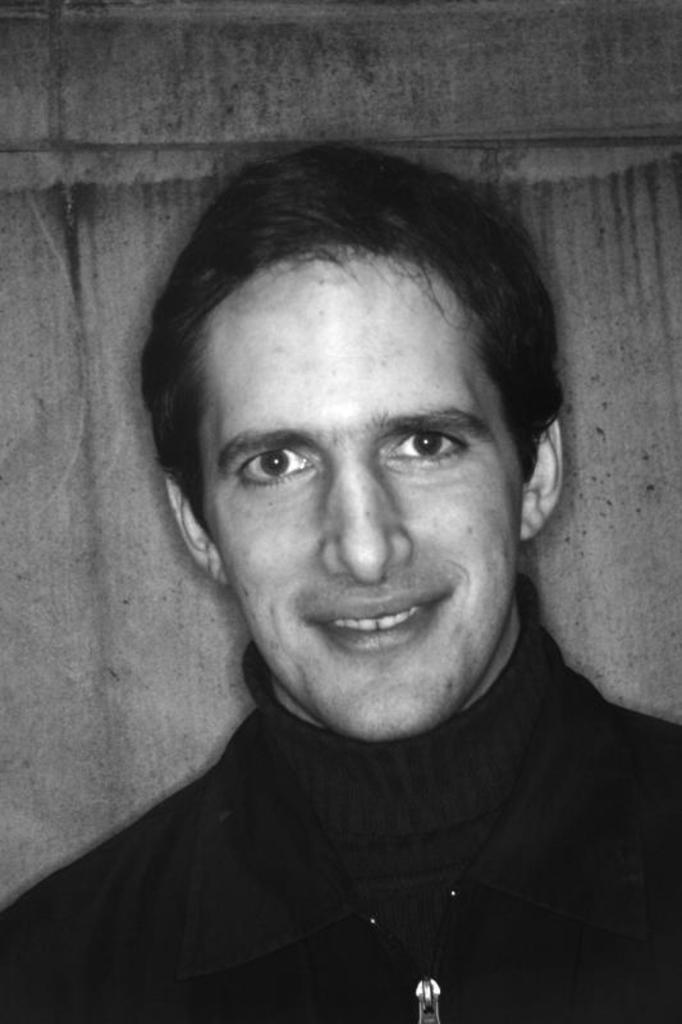Who is the main subject in the image? There is a man in the image. Where is the man positioned in the image? The man is in the front of the image. What is the man's facial expression in the image? The man is smiling in the image. What is the color scheme of the image? The image is black and white in color. What rule does the man establish for the upcoming voyage in the image? There is no mention of a voyage or any rules in the image; it simply shows a man smiling in the front. 